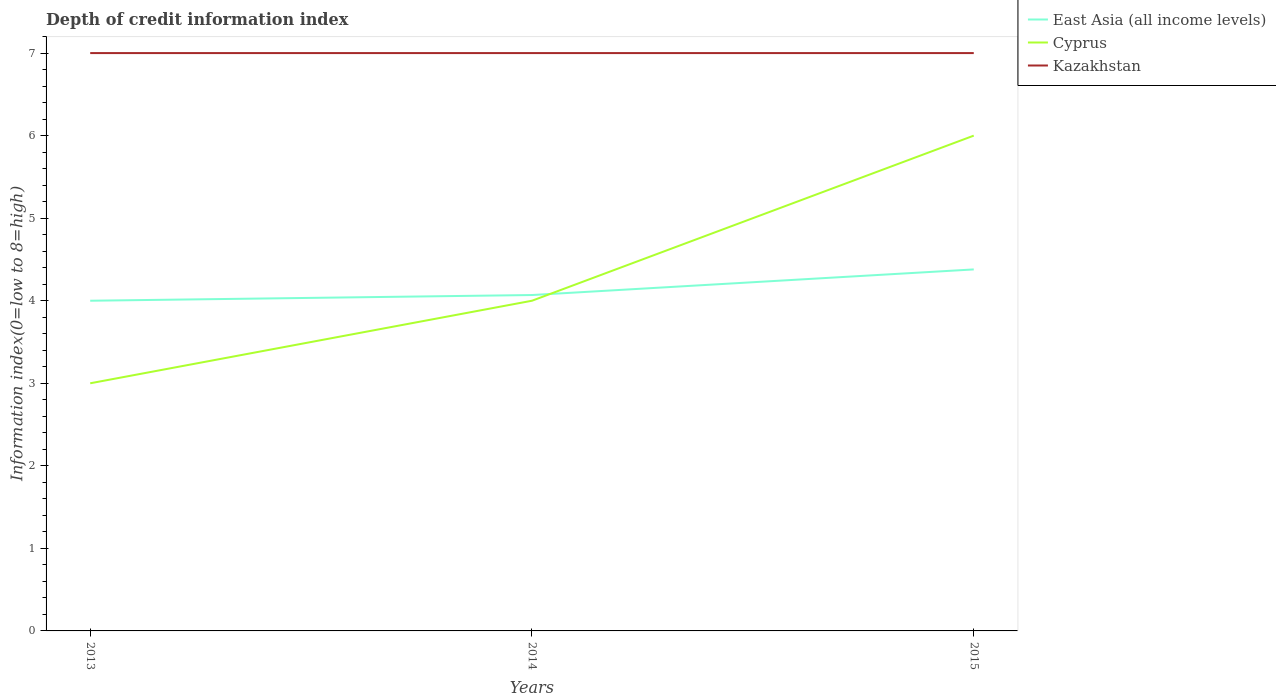How many different coloured lines are there?
Provide a succinct answer. 3. Does the line corresponding to Cyprus intersect with the line corresponding to East Asia (all income levels)?
Offer a very short reply. Yes. Is the number of lines equal to the number of legend labels?
Give a very brief answer. Yes. Across all years, what is the maximum information index in Cyprus?
Provide a short and direct response. 3. What is the total information index in Cyprus in the graph?
Provide a short and direct response. -2. What is the difference between the highest and the second highest information index in Cyprus?
Give a very brief answer. 3. What is the difference between the highest and the lowest information index in Cyprus?
Make the answer very short. 1. Is the information index in Cyprus strictly greater than the information index in East Asia (all income levels) over the years?
Provide a short and direct response. No. How many lines are there?
Offer a very short reply. 3. What is the difference between two consecutive major ticks on the Y-axis?
Your response must be concise. 1. Are the values on the major ticks of Y-axis written in scientific E-notation?
Offer a very short reply. No. How are the legend labels stacked?
Provide a succinct answer. Vertical. What is the title of the graph?
Provide a short and direct response. Depth of credit information index. Does "Gabon" appear as one of the legend labels in the graph?
Provide a succinct answer. No. What is the label or title of the Y-axis?
Your answer should be very brief. Information index(0=low to 8=high). What is the Information index(0=low to 8=high) of Cyprus in 2013?
Your answer should be compact. 3. What is the Information index(0=low to 8=high) in East Asia (all income levels) in 2014?
Offer a very short reply. 4.07. What is the Information index(0=low to 8=high) of Cyprus in 2014?
Provide a short and direct response. 4. What is the Information index(0=low to 8=high) in Kazakhstan in 2014?
Your answer should be very brief. 7. What is the Information index(0=low to 8=high) in East Asia (all income levels) in 2015?
Your answer should be very brief. 4.38. Across all years, what is the maximum Information index(0=low to 8=high) in East Asia (all income levels)?
Offer a terse response. 4.38. Across all years, what is the maximum Information index(0=low to 8=high) in Kazakhstan?
Provide a succinct answer. 7. Across all years, what is the minimum Information index(0=low to 8=high) of Cyprus?
Offer a very short reply. 3. Across all years, what is the minimum Information index(0=low to 8=high) of Kazakhstan?
Offer a very short reply. 7. What is the total Information index(0=low to 8=high) of East Asia (all income levels) in the graph?
Make the answer very short. 12.45. What is the total Information index(0=low to 8=high) in Kazakhstan in the graph?
Keep it short and to the point. 21. What is the difference between the Information index(0=low to 8=high) of East Asia (all income levels) in 2013 and that in 2014?
Offer a very short reply. -0.07. What is the difference between the Information index(0=low to 8=high) of Kazakhstan in 2013 and that in 2014?
Provide a succinct answer. 0. What is the difference between the Information index(0=low to 8=high) in East Asia (all income levels) in 2013 and that in 2015?
Your answer should be compact. -0.38. What is the difference between the Information index(0=low to 8=high) in Kazakhstan in 2013 and that in 2015?
Your answer should be very brief. 0. What is the difference between the Information index(0=low to 8=high) of East Asia (all income levels) in 2014 and that in 2015?
Keep it short and to the point. -0.31. What is the difference between the Information index(0=low to 8=high) of Cyprus in 2014 and that in 2015?
Your answer should be compact. -2. What is the difference between the Information index(0=low to 8=high) in Kazakhstan in 2014 and that in 2015?
Give a very brief answer. 0. What is the difference between the Information index(0=low to 8=high) of East Asia (all income levels) in 2013 and the Information index(0=low to 8=high) of Cyprus in 2014?
Your answer should be very brief. 0. What is the difference between the Information index(0=low to 8=high) of Cyprus in 2013 and the Information index(0=low to 8=high) of Kazakhstan in 2014?
Give a very brief answer. -4. What is the difference between the Information index(0=low to 8=high) of Cyprus in 2013 and the Information index(0=low to 8=high) of Kazakhstan in 2015?
Make the answer very short. -4. What is the difference between the Information index(0=low to 8=high) in East Asia (all income levels) in 2014 and the Information index(0=low to 8=high) in Cyprus in 2015?
Give a very brief answer. -1.93. What is the difference between the Information index(0=low to 8=high) in East Asia (all income levels) in 2014 and the Information index(0=low to 8=high) in Kazakhstan in 2015?
Your answer should be very brief. -2.93. What is the average Information index(0=low to 8=high) in East Asia (all income levels) per year?
Offer a very short reply. 4.15. What is the average Information index(0=low to 8=high) in Cyprus per year?
Give a very brief answer. 4.33. In the year 2013, what is the difference between the Information index(0=low to 8=high) of East Asia (all income levels) and Information index(0=low to 8=high) of Cyprus?
Your answer should be very brief. 1. In the year 2013, what is the difference between the Information index(0=low to 8=high) in East Asia (all income levels) and Information index(0=low to 8=high) in Kazakhstan?
Your response must be concise. -3. In the year 2014, what is the difference between the Information index(0=low to 8=high) in East Asia (all income levels) and Information index(0=low to 8=high) in Cyprus?
Provide a short and direct response. 0.07. In the year 2014, what is the difference between the Information index(0=low to 8=high) of East Asia (all income levels) and Information index(0=low to 8=high) of Kazakhstan?
Give a very brief answer. -2.93. In the year 2014, what is the difference between the Information index(0=low to 8=high) of Cyprus and Information index(0=low to 8=high) of Kazakhstan?
Your response must be concise. -3. In the year 2015, what is the difference between the Information index(0=low to 8=high) of East Asia (all income levels) and Information index(0=low to 8=high) of Cyprus?
Offer a very short reply. -1.62. In the year 2015, what is the difference between the Information index(0=low to 8=high) of East Asia (all income levels) and Information index(0=low to 8=high) of Kazakhstan?
Your answer should be compact. -2.62. What is the ratio of the Information index(0=low to 8=high) in East Asia (all income levels) in 2013 to that in 2014?
Ensure brevity in your answer.  0.98. What is the ratio of the Information index(0=low to 8=high) in Cyprus in 2013 to that in 2014?
Your response must be concise. 0.75. What is the ratio of the Information index(0=low to 8=high) of Kazakhstan in 2013 to that in 2014?
Your answer should be very brief. 1. What is the ratio of the Information index(0=low to 8=high) in East Asia (all income levels) in 2013 to that in 2015?
Make the answer very short. 0.91. What is the ratio of the Information index(0=low to 8=high) in Kazakhstan in 2013 to that in 2015?
Provide a succinct answer. 1. What is the ratio of the Information index(0=low to 8=high) of East Asia (all income levels) in 2014 to that in 2015?
Make the answer very short. 0.93. What is the ratio of the Information index(0=low to 8=high) in Cyprus in 2014 to that in 2015?
Provide a succinct answer. 0.67. What is the difference between the highest and the second highest Information index(0=low to 8=high) of East Asia (all income levels)?
Give a very brief answer. 0.31. What is the difference between the highest and the second highest Information index(0=low to 8=high) in Cyprus?
Your answer should be compact. 2. What is the difference between the highest and the second highest Information index(0=low to 8=high) in Kazakhstan?
Offer a terse response. 0. What is the difference between the highest and the lowest Information index(0=low to 8=high) of East Asia (all income levels)?
Your response must be concise. 0.38. What is the difference between the highest and the lowest Information index(0=low to 8=high) of Kazakhstan?
Provide a short and direct response. 0. 